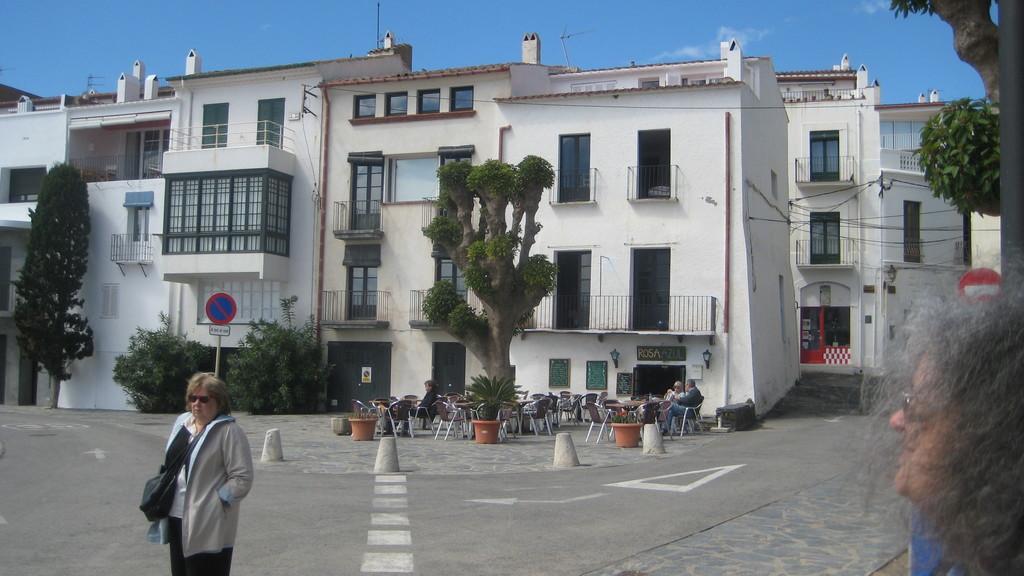Can you describe this image briefly? In this image I can see a person standing wearing cream color jacket, black pant. Background I can see trees in green color, few chairs, building in white color and sky in blue color. 